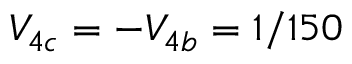Convert formula to latex. <formula><loc_0><loc_0><loc_500><loc_500>V _ { 4 c } = - V _ { 4 b } = 1 / 1 5 0</formula> 